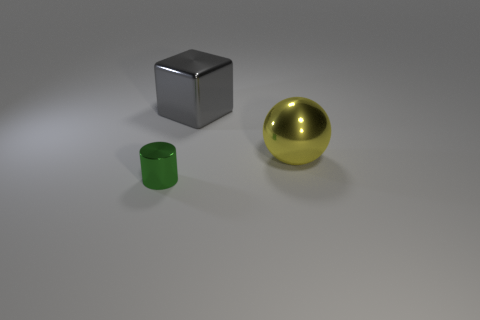Do the green thing and the large object behind the yellow ball have the same shape? no 